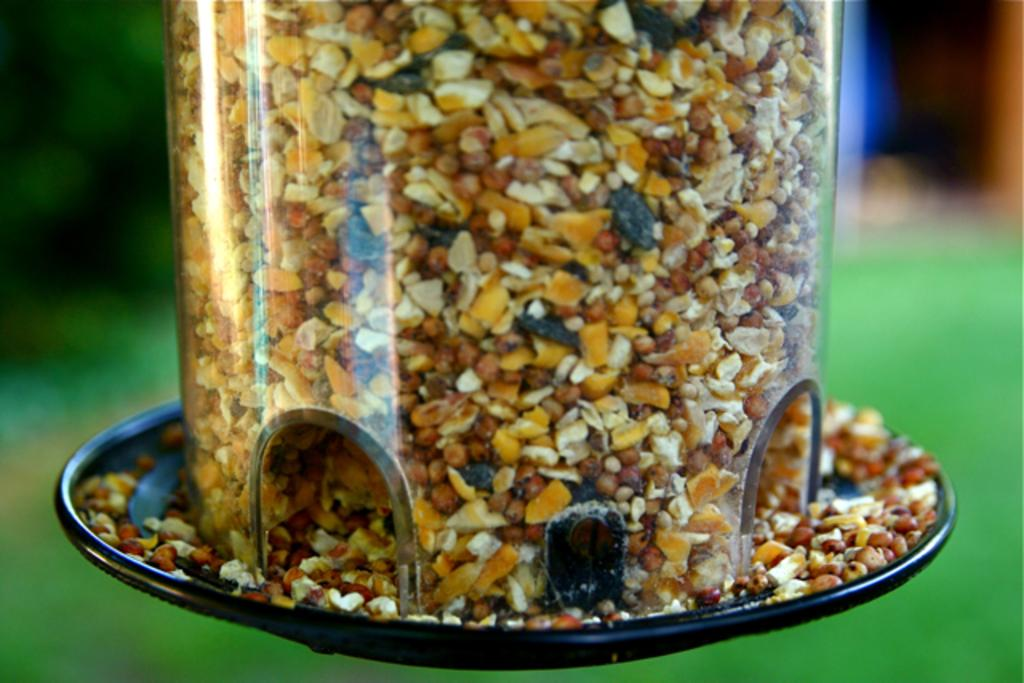What object is the main focus of the image? There is a jar in the image. What is inside the jar? The jar is filled with grains. Can you describe the background of the image? The background of the image is blurred. How many kittens are on the list in the image? There is no list or kittens present in the image. 